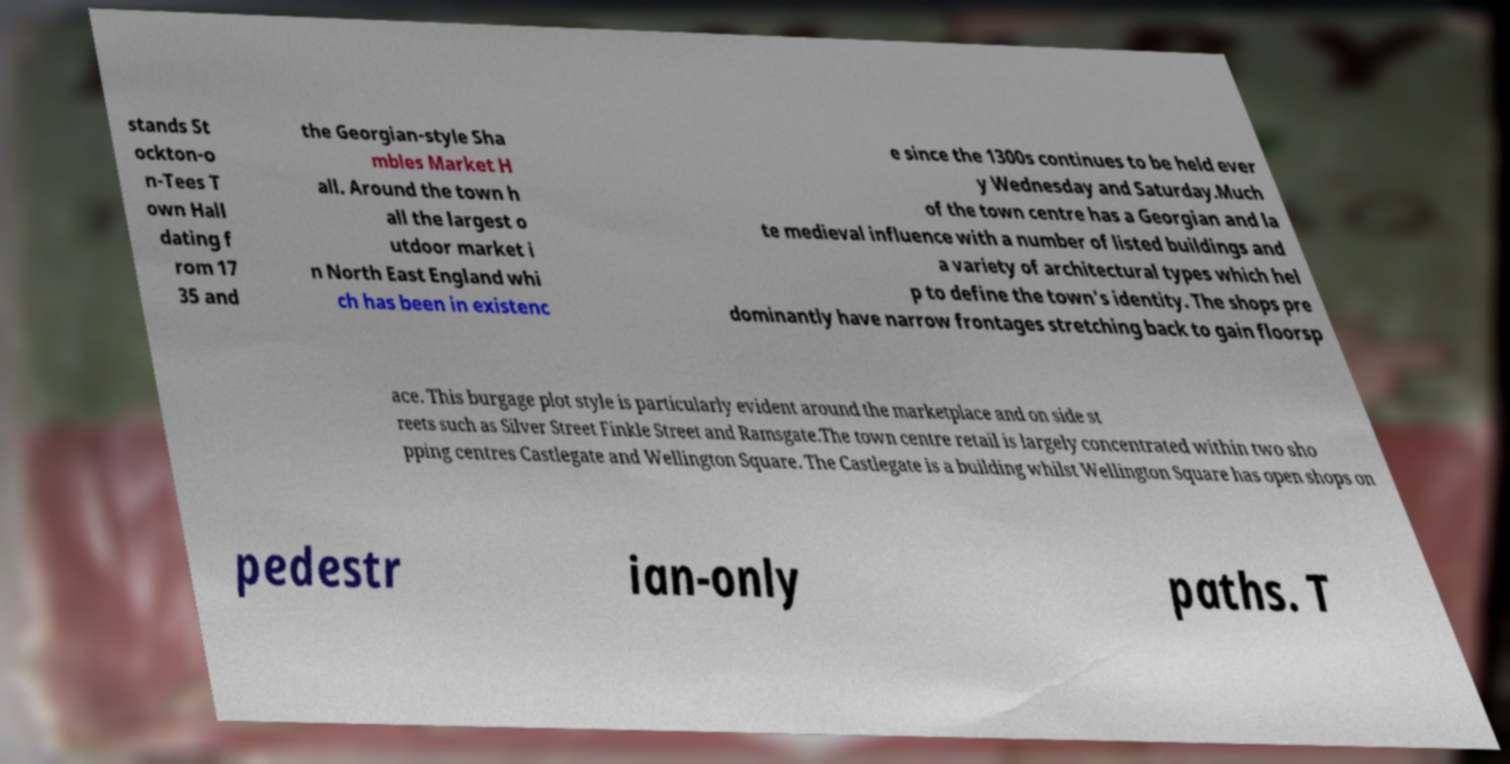I need the written content from this picture converted into text. Can you do that? stands St ockton-o n-Tees T own Hall dating f rom 17 35 and the Georgian-style Sha mbles Market H all. Around the town h all the largest o utdoor market i n North East England whi ch has been in existenc e since the 1300s continues to be held ever y Wednesday and Saturday.Much of the town centre has a Georgian and la te medieval influence with a number of listed buildings and a variety of architectural types which hel p to define the town's identity. The shops pre dominantly have narrow frontages stretching back to gain floorsp ace. This burgage plot style is particularly evident around the marketplace and on side st reets such as Silver Street Finkle Street and Ramsgate.The town centre retail is largely concentrated within two sho pping centres Castlegate and Wellington Square. The Castlegate is a building whilst Wellington Square has open shops on pedestr ian-only paths. T 